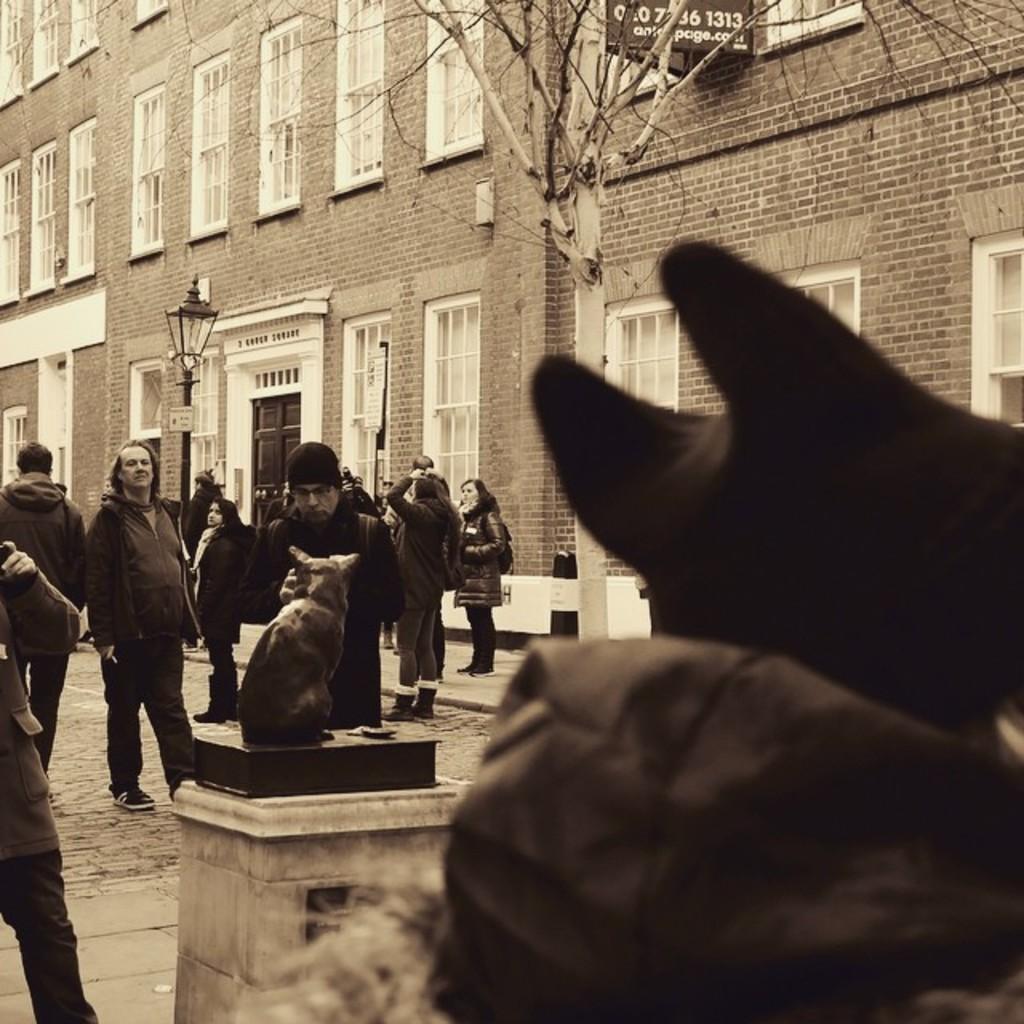Describe this image in one or two sentences. In this picture few persons are standing on the road. Few persons are standing on the pavement. Left side there is a statue on the pillar. There is a street light on the pavement. Background there is a building having a board attached to it. Before it there is a tree on the pavement. Right side there is an object. 